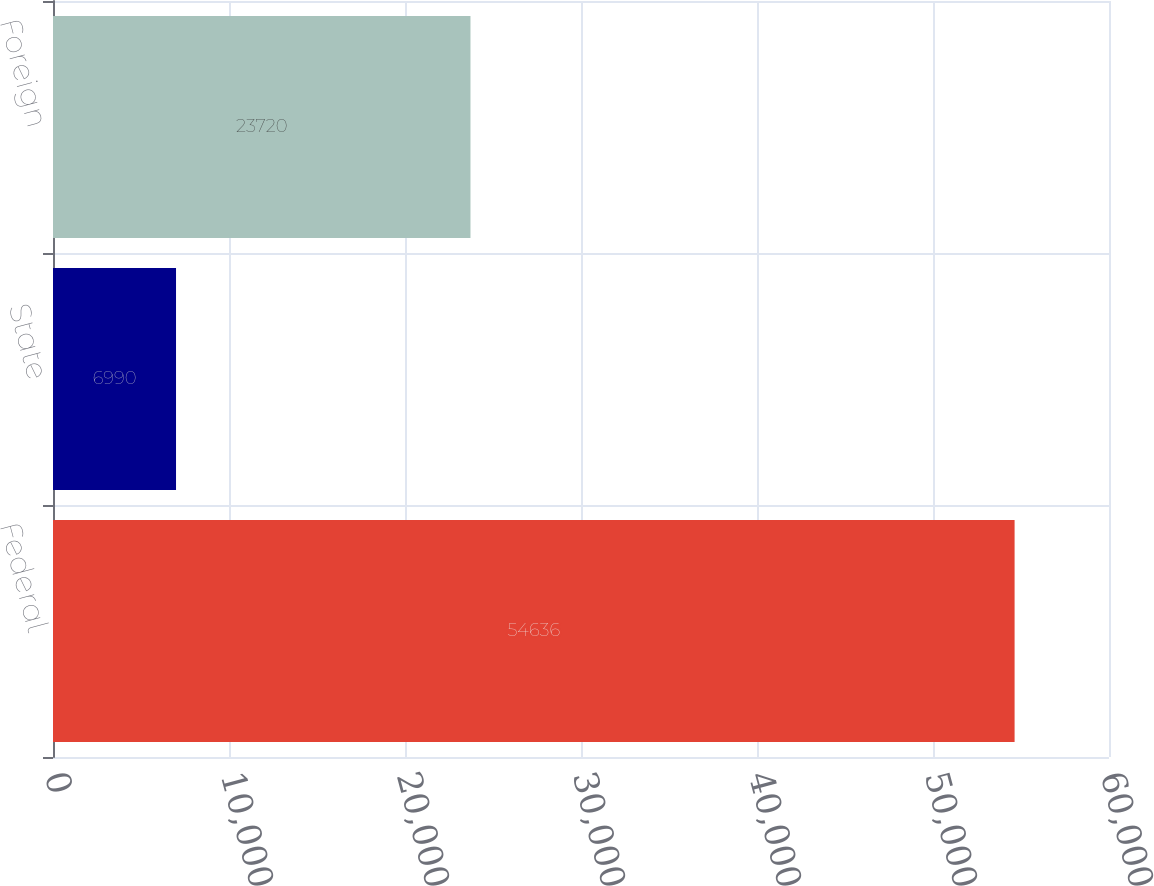Convert chart to OTSL. <chart><loc_0><loc_0><loc_500><loc_500><bar_chart><fcel>Federal<fcel>State<fcel>Foreign<nl><fcel>54636<fcel>6990<fcel>23720<nl></chart> 